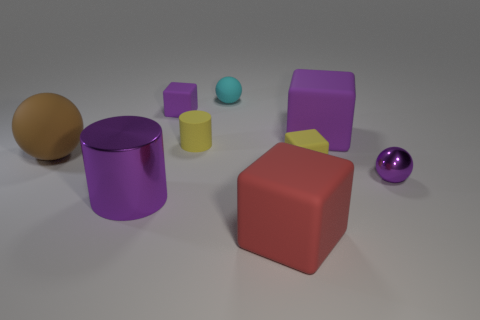Add 1 small purple metal spheres. How many objects exist? 10 Subtract all cylinders. How many objects are left? 7 Subtract all yellow cubes. How many cubes are left? 3 Subtract 2 blocks. How many blocks are left? 2 Subtract all red blocks. How many yellow cylinders are left? 1 Subtract all small gray shiny cubes. Subtract all yellow blocks. How many objects are left? 8 Add 9 tiny purple metallic spheres. How many tiny purple metallic spheres are left? 10 Add 3 large gray blocks. How many large gray blocks exist? 3 Subtract all red cubes. How many cubes are left? 3 Subtract 1 brown spheres. How many objects are left? 8 